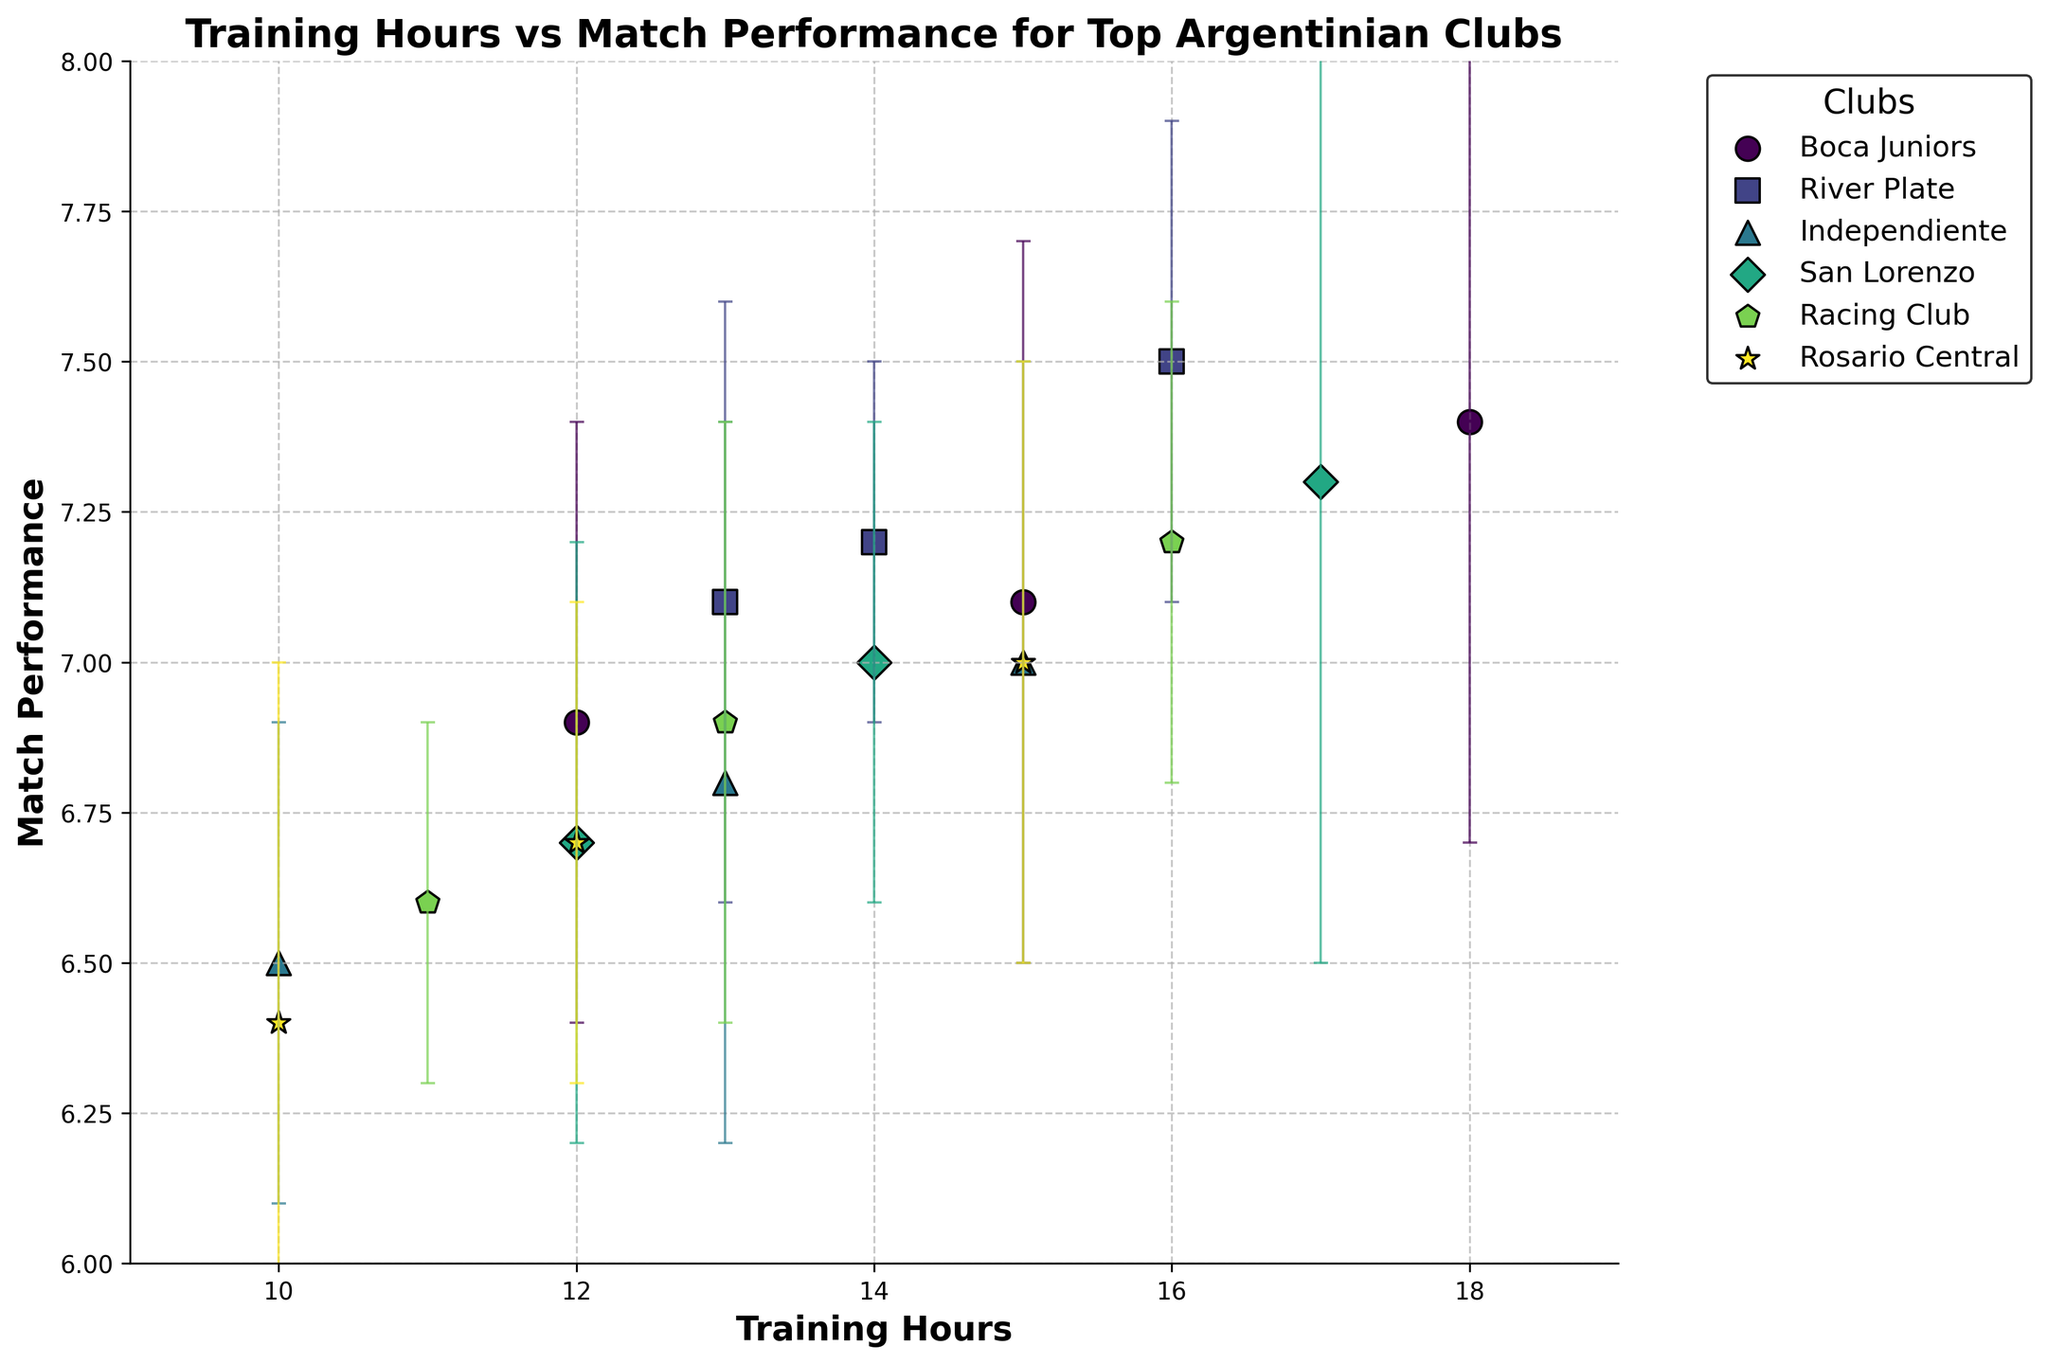What is the title of the plot? The plot's title is displayed prominently at the top of the figure. It provides a summary of the data being presented.
Answer: Training Hours vs Match Performance for Top Argentinian Clubs Which club has the highest match performance for the highest training hours? Locate the club with the highest training hours and then find the corresponding match performance. The highest training hours belong to Boca Juniors with 18 hours and match performance of 7.4.
Answer: Boca Juniors What is the range of the x-axis? Examine the x-axis to determine its minimum and maximum values. The axis starts at 9 and ends at 19.
Answer: 9 to 19 How many data points does Independiente have on the plot? Count the distinct data points (markers) corresponding to Independiente in the figure. Independiente has 3 data points.
Answer: 3 Which club has the smallest error margin in match performance? Observe the error bars for each club and identify the smallest one. River Plate has the smallest error margin of 0.3.
Answer: River Plate Between Boca Juniors and River Plate, which club generally has a higher match performance? Compare the match performance values for data points associated with Boca Juniors and River Plate. River Plate generally has higher match performance.
Answer: River Plate Which club's data points have the largest spread in training hours? Examine the range of training hours for each club. San Lorenzo's training hours range from 12 to 17.
Answer: San Lorenzo What is the average match performance for Racing Club? Sum up the match performance values for Racing Club and divide by the number of its data points. (6.6 + 7.2 + 6.9) / 3 = 6.9
Answer: 6.9 Which club has an outlier in training hours, and what is the value of that outlier? Look for a data point significantly separated from the rest. Boca Juniors has an outlier of 18 training hours.
Answer: Boca Juniors, 18 What is the trend observed between training hours and match performance? Analyze the general direction of data points considering both axes. Match performance tends to increase with training hours.
Answer: Positive correlation 